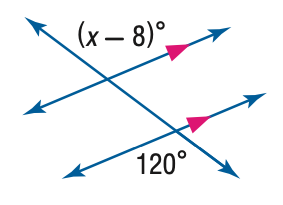Answer the mathemtical geometry problem and directly provide the correct option letter.
Question: Find the value of x in the figure below.
Choices: A: 68 B: 112 C: 120 D: 128 D 